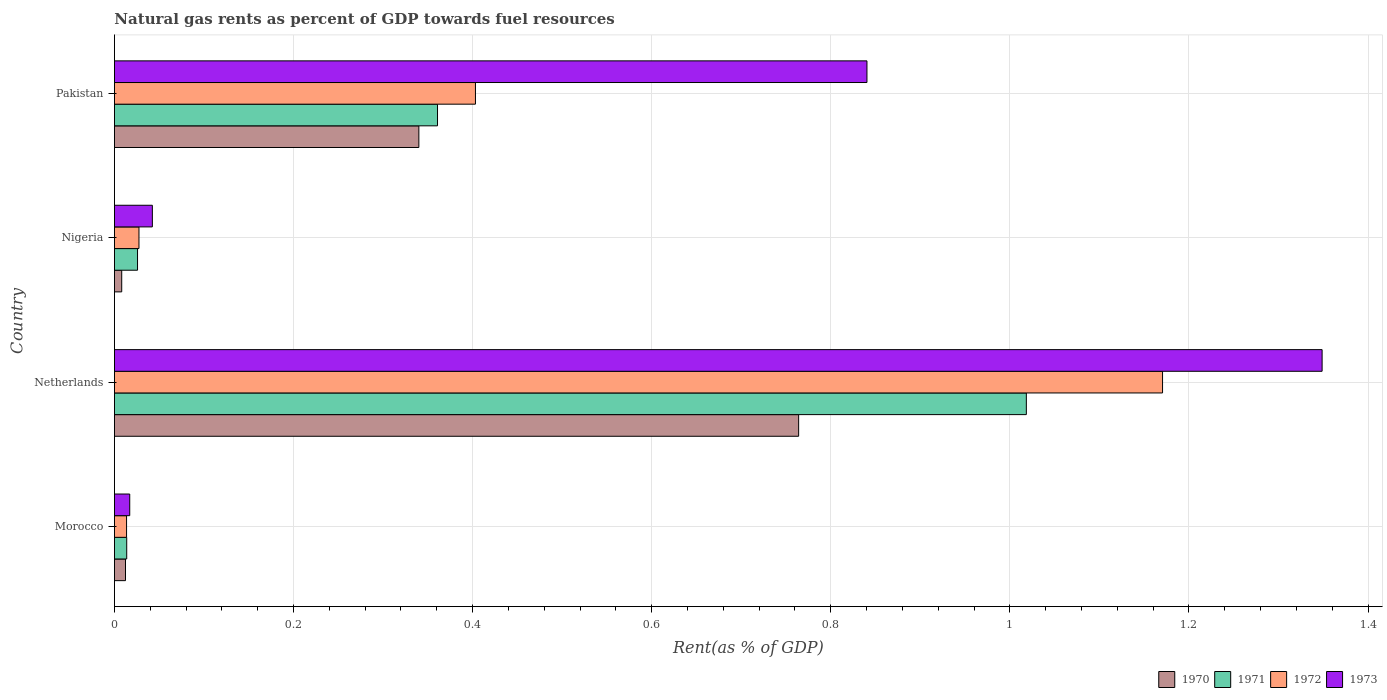How many groups of bars are there?
Offer a terse response. 4. Are the number of bars per tick equal to the number of legend labels?
Provide a short and direct response. Yes. Are the number of bars on each tick of the Y-axis equal?
Offer a very short reply. Yes. How many bars are there on the 4th tick from the top?
Your answer should be compact. 4. How many bars are there on the 4th tick from the bottom?
Keep it short and to the point. 4. What is the label of the 2nd group of bars from the top?
Keep it short and to the point. Nigeria. What is the matural gas rent in 1973 in Netherlands?
Keep it short and to the point. 1.35. Across all countries, what is the maximum matural gas rent in 1972?
Your response must be concise. 1.17. Across all countries, what is the minimum matural gas rent in 1970?
Make the answer very short. 0.01. In which country was the matural gas rent in 1973 maximum?
Ensure brevity in your answer.  Netherlands. In which country was the matural gas rent in 1971 minimum?
Ensure brevity in your answer.  Morocco. What is the total matural gas rent in 1972 in the graph?
Keep it short and to the point. 1.61. What is the difference between the matural gas rent in 1971 in Morocco and that in Netherlands?
Provide a short and direct response. -1. What is the difference between the matural gas rent in 1970 in Netherlands and the matural gas rent in 1971 in Pakistan?
Your response must be concise. 0.4. What is the average matural gas rent in 1971 per country?
Ensure brevity in your answer.  0.35. What is the difference between the matural gas rent in 1972 and matural gas rent in 1971 in Netherlands?
Give a very brief answer. 0.15. In how many countries, is the matural gas rent in 1970 greater than 1.08 %?
Make the answer very short. 0. What is the ratio of the matural gas rent in 1970 in Morocco to that in Nigeria?
Your response must be concise. 1.52. What is the difference between the highest and the second highest matural gas rent in 1971?
Your answer should be very brief. 0.66. What is the difference between the highest and the lowest matural gas rent in 1970?
Provide a succinct answer. 0.76. In how many countries, is the matural gas rent in 1971 greater than the average matural gas rent in 1971 taken over all countries?
Offer a terse response. 2. Is it the case that in every country, the sum of the matural gas rent in 1970 and matural gas rent in 1971 is greater than the sum of matural gas rent in 1973 and matural gas rent in 1972?
Make the answer very short. No. What does the 1st bar from the top in Netherlands represents?
Your answer should be compact. 1973. Are all the bars in the graph horizontal?
Provide a short and direct response. Yes. What is the difference between two consecutive major ticks on the X-axis?
Provide a short and direct response. 0.2. How are the legend labels stacked?
Ensure brevity in your answer.  Horizontal. What is the title of the graph?
Give a very brief answer. Natural gas rents as percent of GDP towards fuel resources. What is the label or title of the X-axis?
Make the answer very short. Rent(as % of GDP). What is the Rent(as % of GDP) in 1970 in Morocco?
Keep it short and to the point. 0.01. What is the Rent(as % of GDP) in 1971 in Morocco?
Offer a terse response. 0.01. What is the Rent(as % of GDP) in 1972 in Morocco?
Give a very brief answer. 0.01. What is the Rent(as % of GDP) of 1973 in Morocco?
Provide a short and direct response. 0.02. What is the Rent(as % of GDP) of 1970 in Netherlands?
Your answer should be compact. 0.76. What is the Rent(as % of GDP) of 1971 in Netherlands?
Your answer should be very brief. 1.02. What is the Rent(as % of GDP) in 1972 in Netherlands?
Your answer should be compact. 1.17. What is the Rent(as % of GDP) of 1973 in Netherlands?
Your response must be concise. 1.35. What is the Rent(as % of GDP) of 1970 in Nigeria?
Your response must be concise. 0.01. What is the Rent(as % of GDP) in 1971 in Nigeria?
Provide a short and direct response. 0.03. What is the Rent(as % of GDP) of 1972 in Nigeria?
Provide a succinct answer. 0.03. What is the Rent(as % of GDP) in 1973 in Nigeria?
Keep it short and to the point. 0.04. What is the Rent(as % of GDP) in 1970 in Pakistan?
Ensure brevity in your answer.  0.34. What is the Rent(as % of GDP) of 1971 in Pakistan?
Your answer should be very brief. 0.36. What is the Rent(as % of GDP) in 1972 in Pakistan?
Give a very brief answer. 0.4. What is the Rent(as % of GDP) in 1973 in Pakistan?
Make the answer very short. 0.84. Across all countries, what is the maximum Rent(as % of GDP) in 1970?
Your answer should be very brief. 0.76. Across all countries, what is the maximum Rent(as % of GDP) of 1971?
Ensure brevity in your answer.  1.02. Across all countries, what is the maximum Rent(as % of GDP) in 1972?
Provide a succinct answer. 1.17. Across all countries, what is the maximum Rent(as % of GDP) in 1973?
Make the answer very short. 1.35. Across all countries, what is the minimum Rent(as % of GDP) of 1970?
Your answer should be compact. 0.01. Across all countries, what is the minimum Rent(as % of GDP) of 1971?
Offer a very short reply. 0.01. Across all countries, what is the minimum Rent(as % of GDP) in 1972?
Provide a short and direct response. 0.01. Across all countries, what is the minimum Rent(as % of GDP) in 1973?
Give a very brief answer. 0.02. What is the total Rent(as % of GDP) in 1970 in the graph?
Make the answer very short. 1.12. What is the total Rent(as % of GDP) of 1971 in the graph?
Give a very brief answer. 1.42. What is the total Rent(as % of GDP) of 1972 in the graph?
Your answer should be compact. 1.61. What is the total Rent(as % of GDP) in 1973 in the graph?
Make the answer very short. 2.25. What is the difference between the Rent(as % of GDP) of 1970 in Morocco and that in Netherlands?
Make the answer very short. -0.75. What is the difference between the Rent(as % of GDP) of 1971 in Morocco and that in Netherlands?
Your response must be concise. -1. What is the difference between the Rent(as % of GDP) in 1972 in Morocco and that in Netherlands?
Offer a very short reply. -1.16. What is the difference between the Rent(as % of GDP) of 1973 in Morocco and that in Netherlands?
Your response must be concise. -1.33. What is the difference between the Rent(as % of GDP) of 1970 in Morocco and that in Nigeria?
Ensure brevity in your answer.  0. What is the difference between the Rent(as % of GDP) in 1971 in Morocco and that in Nigeria?
Give a very brief answer. -0.01. What is the difference between the Rent(as % of GDP) of 1972 in Morocco and that in Nigeria?
Provide a short and direct response. -0.01. What is the difference between the Rent(as % of GDP) in 1973 in Morocco and that in Nigeria?
Provide a short and direct response. -0.03. What is the difference between the Rent(as % of GDP) in 1970 in Morocco and that in Pakistan?
Offer a terse response. -0.33. What is the difference between the Rent(as % of GDP) in 1971 in Morocco and that in Pakistan?
Your answer should be compact. -0.35. What is the difference between the Rent(as % of GDP) of 1972 in Morocco and that in Pakistan?
Offer a very short reply. -0.39. What is the difference between the Rent(as % of GDP) of 1973 in Morocco and that in Pakistan?
Keep it short and to the point. -0.82. What is the difference between the Rent(as % of GDP) in 1970 in Netherlands and that in Nigeria?
Your answer should be very brief. 0.76. What is the difference between the Rent(as % of GDP) in 1972 in Netherlands and that in Nigeria?
Provide a short and direct response. 1.14. What is the difference between the Rent(as % of GDP) in 1973 in Netherlands and that in Nigeria?
Provide a short and direct response. 1.31. What is the difference between the Rent(as % of GDP) in 1970 in Netherlands and that in Pakistan?
Offer a very short reply. 0.42. What is the difference between the Rent(as % of GDP) in 1971 in Netherlands and that in Pakistan?
Provide a succinct answer. 0.66. What is the difference between the Rent(as % of GDP) of 1972 in Netherlands and that in Pakistan?
Give a very brief answer. 0.77. What is the difference between the Rent(as % of GDP) in 1973 in Netherlands and that in Pakistan?
Ensure brevity in your answer.  0.51. What is the difference between the Rent(as % of GDP) in 1970 in Nigeria and that in Pakistan?
Your answer should be compact. -0.33. What is the difference between the Rent(as % of GDP) in 1971 in Nigeria and that in Pakistan?
Make the answer very short. -0.34. What is the difference between the Rent(as % of GDP) of 1972 in Nigeria and that in Pakistan?
Offer a terse response. -0.38. What is the difference between the Rent(as % of GDP) of 1973 in Nigeria and that in Pakistan?
Provide a short and direct response. -0.8. What is the difference between the Rent(as % of GDP) of 1970 in Morocco and the Rent(as % of GDP) of 1971 in Netherlands?
Give a very brief answer. -1.01. What is the difference between the Rent(as % of GDP) in 1970 in Morocco and the Rent(as % of GDP) in 1972 in Netherlands?
Give a very brief answer. -1.16. What is the difference between the Rent(as % of GDP) of 1970 in Morocco and the Rent(as % of GDP) of 1973 in Netherlands?
Give a very brief answer. -1.34. What is the difference between the Rent(as % of GDP) of 1971 in Morocco and the Rent(as % of GDP) of 1972 in Netherlands?
Keep it short and to the point. -1.16. What is the difference between the Rent(as % of GDP) of 1971 in Morocco and the Rent(as % of GDP) of 1973 in Netherlands?
Keep it short and to the point. -1.33. What is the difference between the Rent(as % of GDP) in 1972 in Morocco and the Rent(as % of GDP) in 1973 in Netherlands?
Ensure brevity in your answer.  -1.34. What is the difference between the Rent(as % of GDP) in 1970 in Morocco and the Rent(as % of GDP) in 1971 in Nigeria?
Give a very brief answer. -0.01. What is the difference between the Rent(as % of GDP) of 1970 in Morocco and the Rent(as % of GDP) of 1972 in Nigeria?
Your response must be concise. -0.02. What is the difference between the Rent(as % of GDP) of 1970 in Morocco and the Rent(as % of GDP) of 1973 in Nigeria?
Your answer should be very brief. -0.03. What is the difference between the Rent(as % of GDP) of 1971 in Morocco and the Rent(as % of GDP) of 1972 in Nigeria?
Provide a succinct answer. -0.01. What is the difference between the Rent(as % of GDP) in 1971 in Morocco and the Rent(as % of GDP) in 1973 in Nigeria?
Keep it short and to the point. -0.03. What is the difference between the Rent(as % of GDP) in 1972 in Morocco and the Rent(as % of GDP) in 1973 in Nigeria?
Your response must be concise. -0.03. What is the difference between the Rent(as % of GDP) of 1970 in Morocco and the Rent(as % of GDP) of 1971 in Pakistan?
Your answer should be compact. -0.35. What is the difference between the Rent(as % of GDP) of 1970 in Morocco and the Rent(as % of GDP) of 1972 in Pakistan?
Keep it short and to the point. -0.39. What is the difference between the Rent(as % of GDP) of 1970 in Morocco and the Rent(as % of GDP) of 1973 in Pakistan?
Your answer should be compact. -0.83. What is the difference between the Rent(as % of GDP) of 1971 in Morocco and the Rent(as % of GDP) of 1972 in Pakistan?
Provide a succinct answer. -0.39. What is the difference between the Rent(as % of GDP) in 1971 in Morocco and the Rent(as % of GDP) in 1973 in Pakistan?
Offer a terse response. -0.83. What is the difference between the Rent(as % of GDP) in 1972 in Morocco and the Rent(as % of GDP) in 1973 in Pakistan?
Give a very brief answer. -0.83. What is the difference between the Rent(as % of GDP) of 1970 in Netherlands and the Rent(as % of GDP) of 1971 in Nigeria?
Your answer should be compact. 0.74. What is the difference between the Rent(as % of GDP) in 1970 in Netherlands and the Rent(as % of GDP) in 1972 in Nigeria?
Give a very brief answer. 0.74. What is the difference between the Rent(as % of GDP) of 1970 in Netherlands and the Rent(as % of GDP) of 1973 in Nigeria?
Provide a succinct answer. 0.72. What is the difference between the Rent(as % of GDP) in 1971 in Netherlands and the Rent(as % of GDP) in 1972 in Nigeria?
Give a very brief answer. 0.99. What is the difference between the Rent(as % of GDP) of 1972 in Netherlands and the Rent(as % of GDP) of 1973 in Nigeria?
Your answer should be compact. 1.13. What is the difference between the Rent(as % of GDP) of 1970 in Netherlands and the Rent(as % of GDP) of 1971 in Pakistan?
Make the answer very short. 0.4. What is the difference between the Rent(as % of GDP) of 1970 in Netherlands and the Rent(as % of GDP) of 1972 in Pakistan?
Provide a succinct answer. 0.36. What is the difference between the Rent(as % of GDP) in 1970 in Netherlands and the Rent(as % of GDP) in 1973 in Pakistan?
Provide a succinct answer. -0.08. What is the difference between the Rent(as % of GDP) in 1971 in Netherlands and the Rent(as % of GDP) in 1972 in Pakistan?
Ensure brevity in your answer.  0.62. What is the difference between the Rent(as % of GDP) of 1971 in Netherlands and the Rent(as % of GDP) of 1973 in Pakistan?
Ensure brevity in your answer.  0.18. What is the difference between the Rent(as % of GDP) in 1972 in Netherlands and the Rent(as % of GDP) in 1973 in Pakistan?
Keep it short and to the point. 0.33. What is the difference between the Rent(as % of GDP) in 1970 in Nigeria and the Rent(as % of GDP) in 1971 in Pakistan?
Make the answer very short. -0.35. What is the difference between the Rent(as % of GDP) of 1970 in Nigeria and the Rent(as % of GDP) of 1972 in Pakistan?
Offer a very short reply. -0.4. What is the difference between the Rent(as % of GDP) of 1970 in Nigeria and the Rent(as % of GDP) of 1973 in Pakistan?
Your answer should be compact. -0.83. What is the difference between the Rent(as % of GDP) in 1971 in Nigeria and the Rent(as % of GDP) in 1972 in Pakistan?
Provide a succinct answer. -0.38. What is the difference between the Rent(as % of GDP) in 1971 in Nigeria and the Rent(as % of GDP) in 1973 in Pakistan?
Keep it short and to the point. -0.81. What is the difference between the Rent(as % of GDP) in 1972 in Nigeria and the Rent(as % of GDP) in 1973 in Pakistan?
Keep it short and to the point. -0.81. What is the average Rent(as % of GDP) in 1970 per country?
Make the answer very short. 0.28. What is the average Rent(as % of GDP) in 1971 per country?
Your answer should be compact. 0.35. What is the average Rent(as % of GDP) in 1972 per country?
Provide a short and direct response. 0.4. What is the average Rent(as % of GDP) in 1973 per country?
Offer a terse response. 0.56. What is the difference between the Rent(as % of GDP) of 1970 and Rent(as % of GDP) of 1971 in Morocco?
Your answer should be compact. -0. What is the difference between the Rent(as % of GDP) in 1970 and Rent(as % of GDP) in 1972 in Morocco?
Provide a succinct answer. -0. What is the difference between the Rent(as % of GDP) of 1970 and Rent(as % of GDP) of 1973 in Morocco?
Provide a succinct answer. -0. What is the difference between the Rent(as % of GDP) in 1971 and Rent(as % of GDP) in 1972 in Morocco?
Provide a succinct answer. 0. What is the difference between the Rent(as % of GDP) of 1971 and Rent(as % of GDP) of 1973 in Morocco?
Keep it short and to the point. -0. What is the difference between the Rent(as % of GDP) in 1972 and Rent(as % of GDP) in 1973 in Morocco?
Keep it short and to the point. -0. What is the difference between the Rent(as % of GDP) in 1970 and Rent(as % of GDP) in 1971 in Netherlands?
Provide a short and direct response. -0.25. What is the difference between the Rent(as % of GDP) of 1970 and Rent(as % of GDP) of 1972 in Netherlands?
Keep it short and to the point. -0.41. What is the difference between the Rent(as % of GDP) in 1970 and Rent(as % of GDP) in 1973 in Netherlands?
Keep it short and to the point. -0.58. What is the difference between the Rent(as % of GDP) of 1971 and Rent(as % of GDP) of 1972 in Netherlands?
Offer a terse response. -0.15. What is the difference between the Rent(as % of GDP) in 1971 and Rent(as % of GDP) in 1973 in Netherlands?
Keep it short and to the point. -0.33. What is the difference between the Rent(as % of GDP) in 1972 and Rent(as % of GDP) in 1973 in Netherlands?
Your answer should be compact. -0.18. What is the difference between the Rent(as % of GDP) in 1970 and Rent(as % of GDP) in 1971 in Nigeria?
Provide a short and direct response. -0.02. What is the difference between the Rent(as % of GDP) in 1970 and Rent(as % of GDP) in 1972 in Nigeria?
Make the answer very short. -0.02. What is the difference between the Rent(as % of GDP) in 1970 and Rent(as % of GDP) in 1973 in Nigeria?
Ensure brevity in your answer.  -0.03. What is the difference between the Rent(as % of GDP) of 1971 and Rent(as % of GDP) of 1972 in Nigeria?
Ensure brevity in your answer.  -0. What is the difference between the Rent(as % of GDP) of 1971 and Rent(as % of GDP) of 1973 in Nigeria?
Make the answer very short. -0.02. What is the difference between the Rent(as % of GDP) in 1972 and Rent(as % of GDP) in 1973 in Nigeria?
Keep it short and to the point. -0.01. What is the difference between the Rent(as % of GDP) of 1970 and Rent(as % of GDP) of 1971 in Pakistan?
Your response must be concise. -0.02. What is the difference between the Rent(as % of GDP) of 1970 and Rent(as % of GDP) of 1972 in Pakistan?
Ensure brevity in your answer.  -0.06. What is the difference between the Rent(as % of GDP) of 1970 and Rent(as % of GDP) of 1973 in Pakistan?
Your response must be concise. -0.5. What is the difference between the Rent(as % of GDP) in 1971 and Rent(as % of GDP) in 1972 in Pakistan?
Keep it short and to the point. -0.04. What is the difference between the Rent(as % of GDP) in 1971 and Rent(as % of GDP) in 1973 in Pakistan?
Make the answer very short. -0.48. What is the difference between the Rent(as % of GDP) in 1972 and Rent(as % of GDP) in 1973 in Pakistan?
Your answer should be compact. -0.44. What is the ratio of the Rent(as % of GDP) of 1970 in Morocco to that in Netherlands?
Offer a terse response. 0.02. What is the ratio of the Rent(as % of GDP) in 1971 in Morocco to that in Netherlands?
Offer a terse response. 0.01. What is the ratio of the Rent(as % of GDP) in 1972 in Morocco to that in Netherlands?
Your answer should be compact. 0.01. What is the ratio of the Rent(as % of GDP) of 1973 in Morocco to that in Netherlands?
Provide a short and direct response. 0.01. What is the ratio of the Rent(as % of GDP) in 1970 in Morocco to that in Nigeria?
Keep it short and to the point. 1.52. What is the ratio of the Rent(as % of GDP) of 1971 in Morocco to that in Nigeria?
Provide a short and direct response. 0.53. What is the ratio of the Rent(as % of GDP) of 1972 in Morocco to that in Nigeria?
Make the answer very short. 0.49. What is the ratio of the Rent(as % of GDP) of 1973 in Morocco to that in Nigeria?
Provide a succinct answer. 0.4. What is the ratio of the Rent(as % of GDP) of 1970 in Morocco to that in Pakistan?
Your answer should be compact. 0.04. What is the ratio of the Rent(as % of GDP) in 1971 in Morocco to that in Pakistan?
Make the answer very short. 0.04. What is the ratio of the Rent(as % of GDP) of 1972 in Morocco to that in Pakistan?
Provide a succinct answer. 0.03. What is the ratio of the Rent(as % of GDP) of 1973 in Morocco to that in Pakistan?
Ensure brevity in your answer.  0.02. What is the ratio of the Rent(as % of GDP) in 1970 in Netherlands to that in Nigeria?
Ensure brevity in your answer.  93.94. What is the ratio of the Rent(as % of GDP) of 1971 in Netherlands to that in Nigeria?
Offer a very short reply. 39.48. What is the ratio of the Rent(as % of GDP) in 1972 in Netherlands to that in Nigeria?
Ensure brevity in your answer.  42.7. What is the ratio of the Rent(as % of GDP) of 1973 in Netherlands to that in Nigeria?
Give a very brief answer. 31.84. What is the ratio of the Rent(as % of GDP) of 1970 in Netherlands to that in Pakistan?
Your response must be concise. 2.25. What is the ratio of the Rent(as % of GDP) of 1971 in Netherlands to that in Pakistan?
Provide a succinct answer. 2.82. What is the ratio of the Rent(as % of GDP) in 1972 in Netherlands to that in Pakistan?
Your answer should be compact. 2.9. What is the ratio of the Rent(as % of GDP) of 1973 in Netherlands to that in Pakistan?
Your response must be concise. 1.6. What is the ratio of the Rent(as % of GDP) in 1970 in Nigeria to that in Pakistan?
Your response must be concise. 0.02. What is the ratio of the Rent(as % of GDP) of 1971 in Nigeria to that in Pakistan?
Offer a terse response. 0.07. What is the ratio of the Rent(as % of GDP) of 1972 in Nigeria to that in Pakistan?
Make the answer very short. 0.07. What is the ratio of the Rent(as % of GDP) of 1973 in Nigeria to that in Pakistan?
Give a very brief answer. 0.05. What is the difference between the highest and the second highest Rent(as % of GDP) in 1970?
Your answer should be compact. 0.42. What is the difference between the highest and the second highest Rent(as % of GDP) in 1971?
Provide a short and direct response. 0.66. What is the difference between the highest and the second highest Rent(as % of GDP) of 1972?
Keep it short and to the point. 0.77. What is the difference between the highest and the second highest Rent(as % of GDP) of 1973?
Ensure brevity in your answer.  0.51. What is the difference between the highest and the lowest Rent(as % of GDP) of 1970?
Provide a short and direct response. 0.76. What is the difference between the highest and the lowest Rent(as % of GDP) of 1971?
Keep it short and to the point. 1. What is the difference between the highest and the lowest Rent(as % of GDP) in 1972?
Offer a very short reply. 1.16. What is the difference between the highest and the lowest Rent(as % of GDP) in 1973?
Your answer should be very brief. 1.33. 